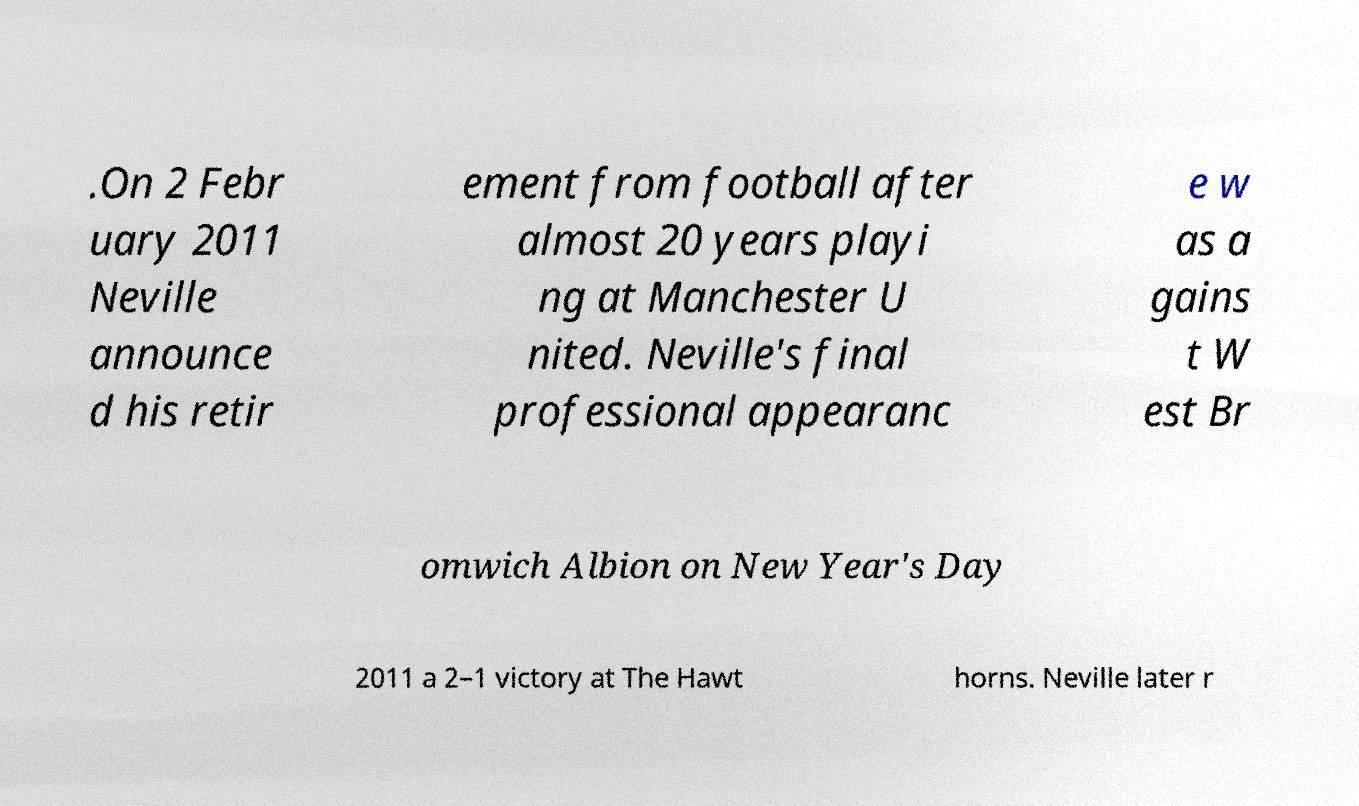Can you accurately transcribe the text from the provided image for me? .On 2 Febr uary 2011 Neville announce d his retir ement from football after almost 20 years playi ng at Manchester U nited. Neville's final professional appearanc e w as a gains t W est Br omwich Albion on New Year's Day 2011 a 2–1 victory at The Hawt horns. Neville later r 